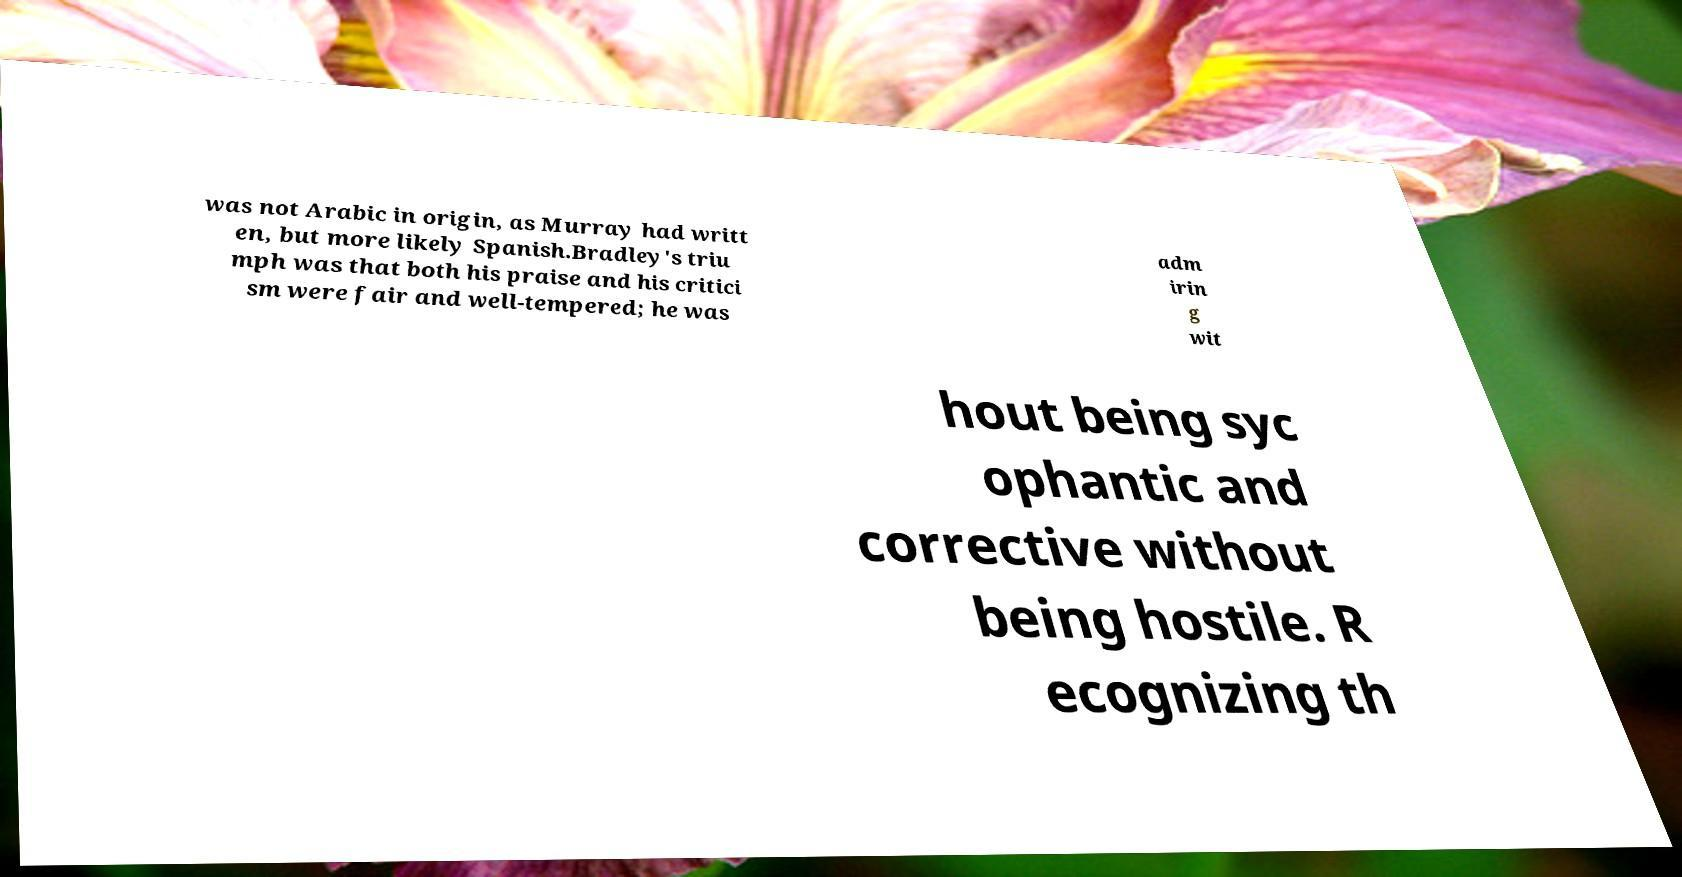I need the written content from this picture converted into text. Can you do that? was not Arabic in origin, as Murray had writt en, but more likely Spanish.Bradley's triu mph was that both his praise and his critici sm were fair and well-tempered; he was adm irin g wit hout being syc ophantic and corrective without being hostile. R ecognizing th 